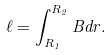Convert formula to latex. <formula><loc_0><loc_0><loc_500><loc_500>\ell = \int _ { R _ { 1 } } ^ { R _ { 2 } } B d r .</formula> 